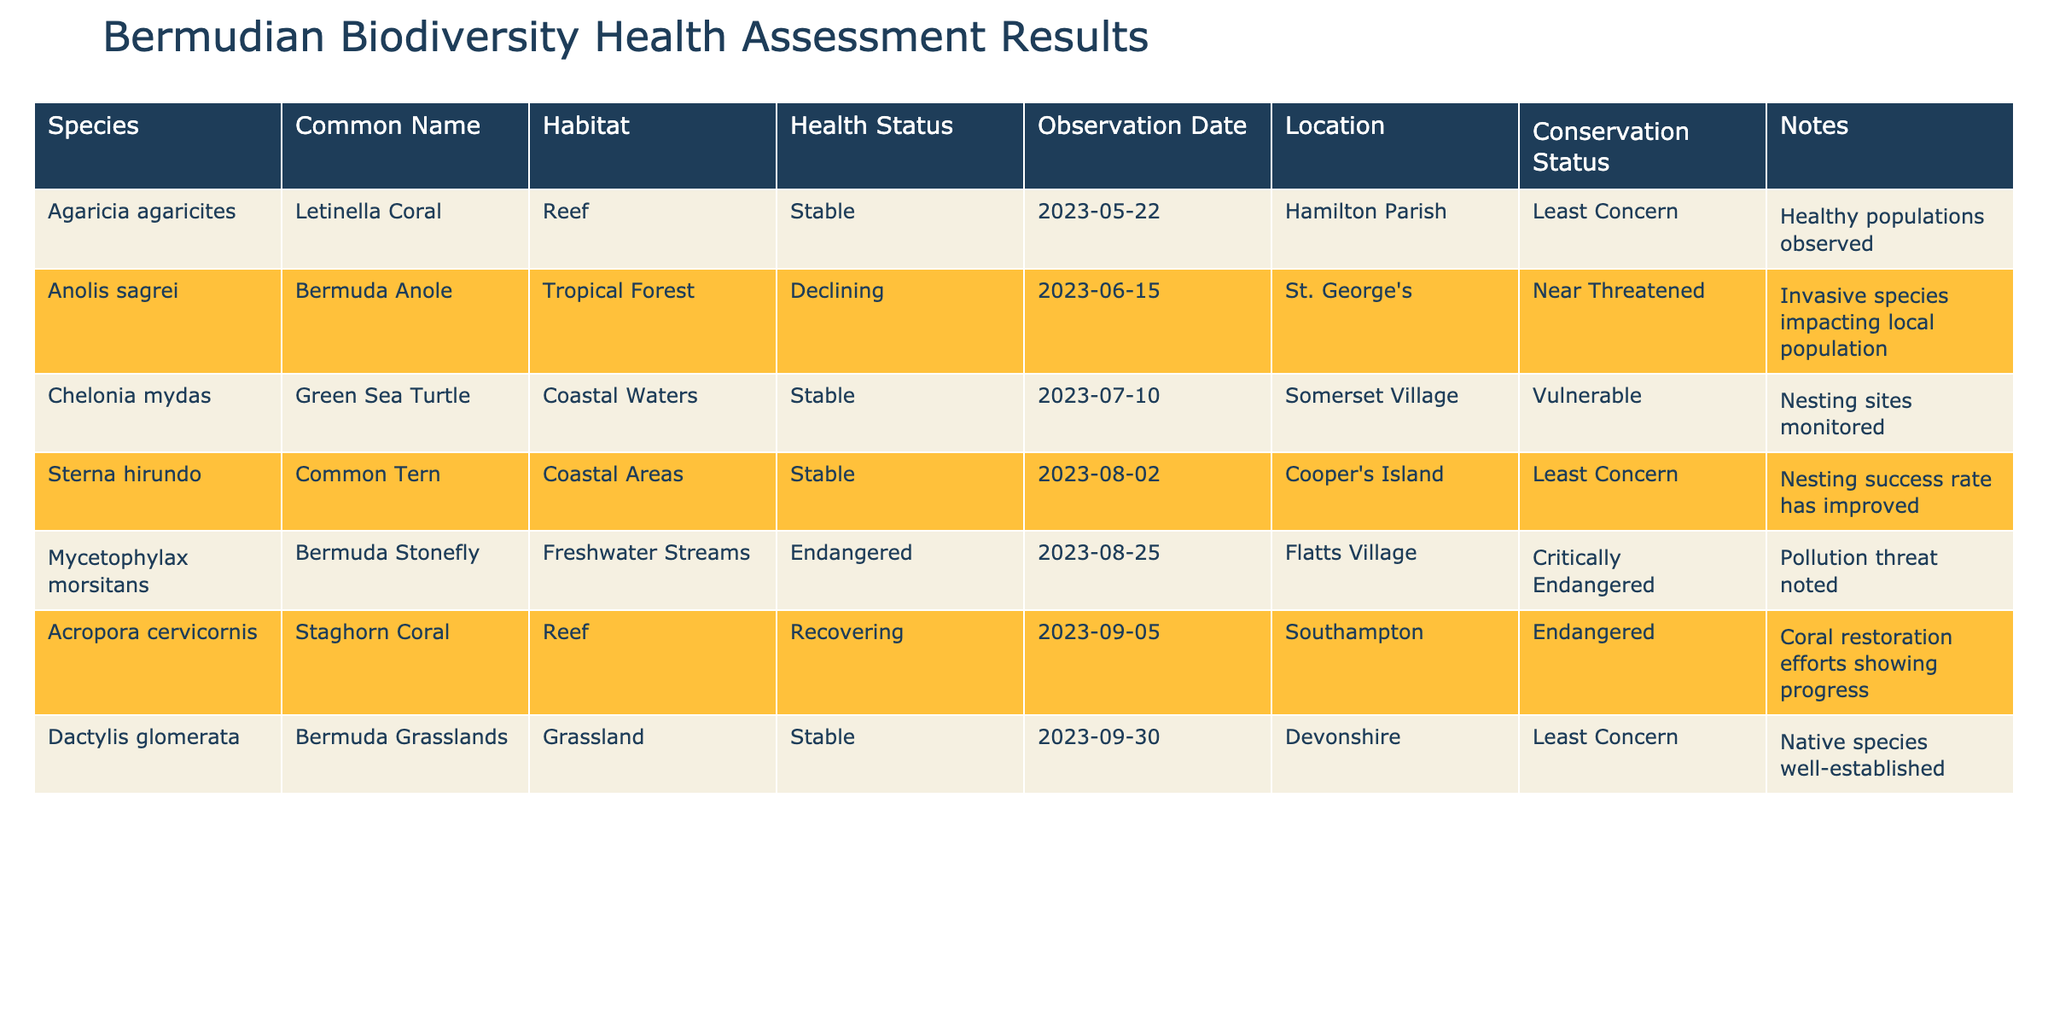What is the health status of the Bermuda Stonefly? The table indicates that the health status of the Bermuda Stonefly (Mycetophylax morsitans) is Endangered.
Answer: Endangered Which species has a "Stable" health status observed in Hamilton Parish? The Letinella Coral (Agaricia agaricites) has a Stable health status and was observed in Hamilton Parish on 2023-05-22.
Answer: Letinella Coral How many species have a health status of "Stable"? There are four species listed with a health status of Stable: Letinella Coral, Green Sea Turtle, Common Tern, and Bermuda Grasslands.
Answer: 4 Is the Bermuda Anole considered a threatened species? Yes, the Bermuda Anole (Anolis sagrei) is classified as Near Threatened, which implies it is under threat.
Answer: Yes What is the difference in conservation status between the Staghorn Coral and the Bermuda Stonefly? The Staghorn Coral (Acropora cervicornis) is classified as Endangered, while the Bermuda Stonefly (Mycetophylax morsitans) is classified as Critically Endangered, indicating the Stonefly is at greater risk.
Answer: Critically Endangered is worse than Endangered Which species is recovering and what conservation efforts are in place? The Staghorn Coral (Acropora cervicornis) is recovering due to coral restoration efforts showing progress. The table indicates that these efforts are specifically focused on the recovery of the coral habitat.
Answer: Staghorn Coral; Coral restoration efforts What is the relationship between the presence of invasive species and the health status of the Bermuda Anole? The Bermuda Anole's health status is Declining, which is attributed to invasive species impacting its local population, suggesting a negative relationship.
Answer: Declining; invasive species impact How many species are listed as "Vulnerable" or worse? In total, there are three species classified as Vulnerable or worse: Green Sea Turtle (Vulnerable), Bermuda Stonefly (Critically Endangered), and Staghorn Coral (Endangered). Thus, we sum the classifications for Vulnerable (1) and below (2).
Answer: 3 